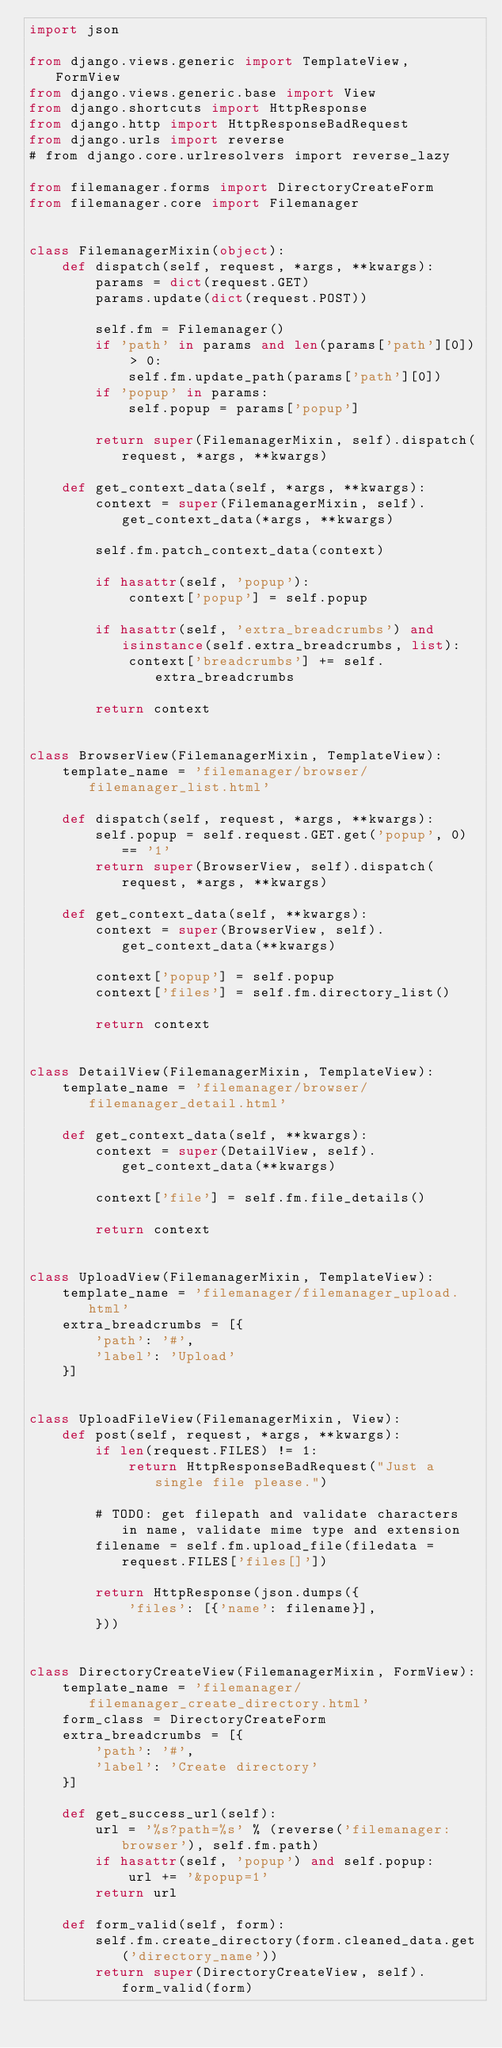<code> <loc_0><loc_0><loc_500><loc_500><_Python_>import json

from django.views.generic import TemplateView, FormView
from django.views.generic.base import View
from django.shortcuts import HttpResponse
from django.http import HttpResponseBadRequest
from django.urls import reverse
# from django.core.urlresolvers import reverse_lazy

from filemanager.forms import DirectoryCreateForm
from filemanager.core import Filemanager


class FilemanagerMixin(object):
    def dispatch(self, request, *args, **kwargs):
        params = dict(request.GET)
        params.update(dict(request.POST))

        self.fm = Filemanager()
        if 'path' in params and len(params['path'][0]) > 0:
            self.fm.update_path(params['path'][0])
        if 'popup' in params:
            self.popup = params['popup']

        return super(FilemanagerMixin, self).dispatch(request, *args, **kwargs)

    def get_context_data(self, *args, **kwargs):
        context = super(FilemanagerMixin, self).get_context_data(*args, **kwargs)

        self.fm.patch_context_data(context)

        if hasattr(self, 'popup'):
            context['popup'] = self.popup

        if hasattr(self, 'extra_breadcrumbs') and isinstance(self.extra_breadcrumbs, list):
            context['breadcrumbs'] += self.extra_breadcrumbs

        return context


class BrowserView(FilemanagerMixin, TemplateView):
    template_name = 'filemanager/browser/filemanager_list.html'

    def dispatch(self, request, *args, **kwargs):
        self.popup = self.request.GET.get('popup', 0) == '1'
        return super(BrowserView, self).dispatch(request, *args, **kwargs)

    def get_context_data(self, **kwargs):
        context = super(BrowserView, self).get_context_data(**kwargs)

        context['popup'] = self.popup
        context['files'] = self.fm.directory_list()

        return context


class DetailView(FilemanagerMixin, TemplateView):
    template_name = 'filemanager/browser/filemanager_detail.html'

    def get_context_data(self, **kwargs):
        context = super(DetailView, self).get_context_data(**kwargs)

        context['file'] = self.fm.file_details()

        return context


class UploadView(FilemanagerMixin, TemplateView):
    template_name = 'filemanager/filemanager_upload.html'
    extra_breadcrumbs = [{
        'path': '#',
        'label': 'Upload'
    }]


class UploadFileView(FilemanagerMixin, View):
    def post(self, request, *args, **kwargs):
        if len(request.FILES) != 1:
            return HttpResponseBadRequest("Just a single file please.")

        # TODO: get filepath and validate characters in name, validate mime type and extension
        filename = self.fm.upload_file(filedata = request.FILES['files[]'])

        return HttpResponse(json.dumps({
            'files': [{'name': filename}],
        }))


class DirectoryCreateView(FilemanagerMixin, FormView):
    template_name = 'filemanager/filemanager_create_directory.html'
    form_class = DirectoryCreateForm
    extra_breadcrumbs = [{
        'path': '#',
        'label': 'Create directory'
    }]

    def get_success_url(self):
        url = '%s?path=%s' % (reverse('filemanager:browser'), self.fm.path)
        if hasattr(self, 'popup') and self.popup:
            url += '&popup=1'
        return url

    def form_valid(self, form):
        self.fm.create_directory(form.cleaned_data.get('directory_name'))
        return super(DirectoryCreateView, self).form_valid(form)
</code> 